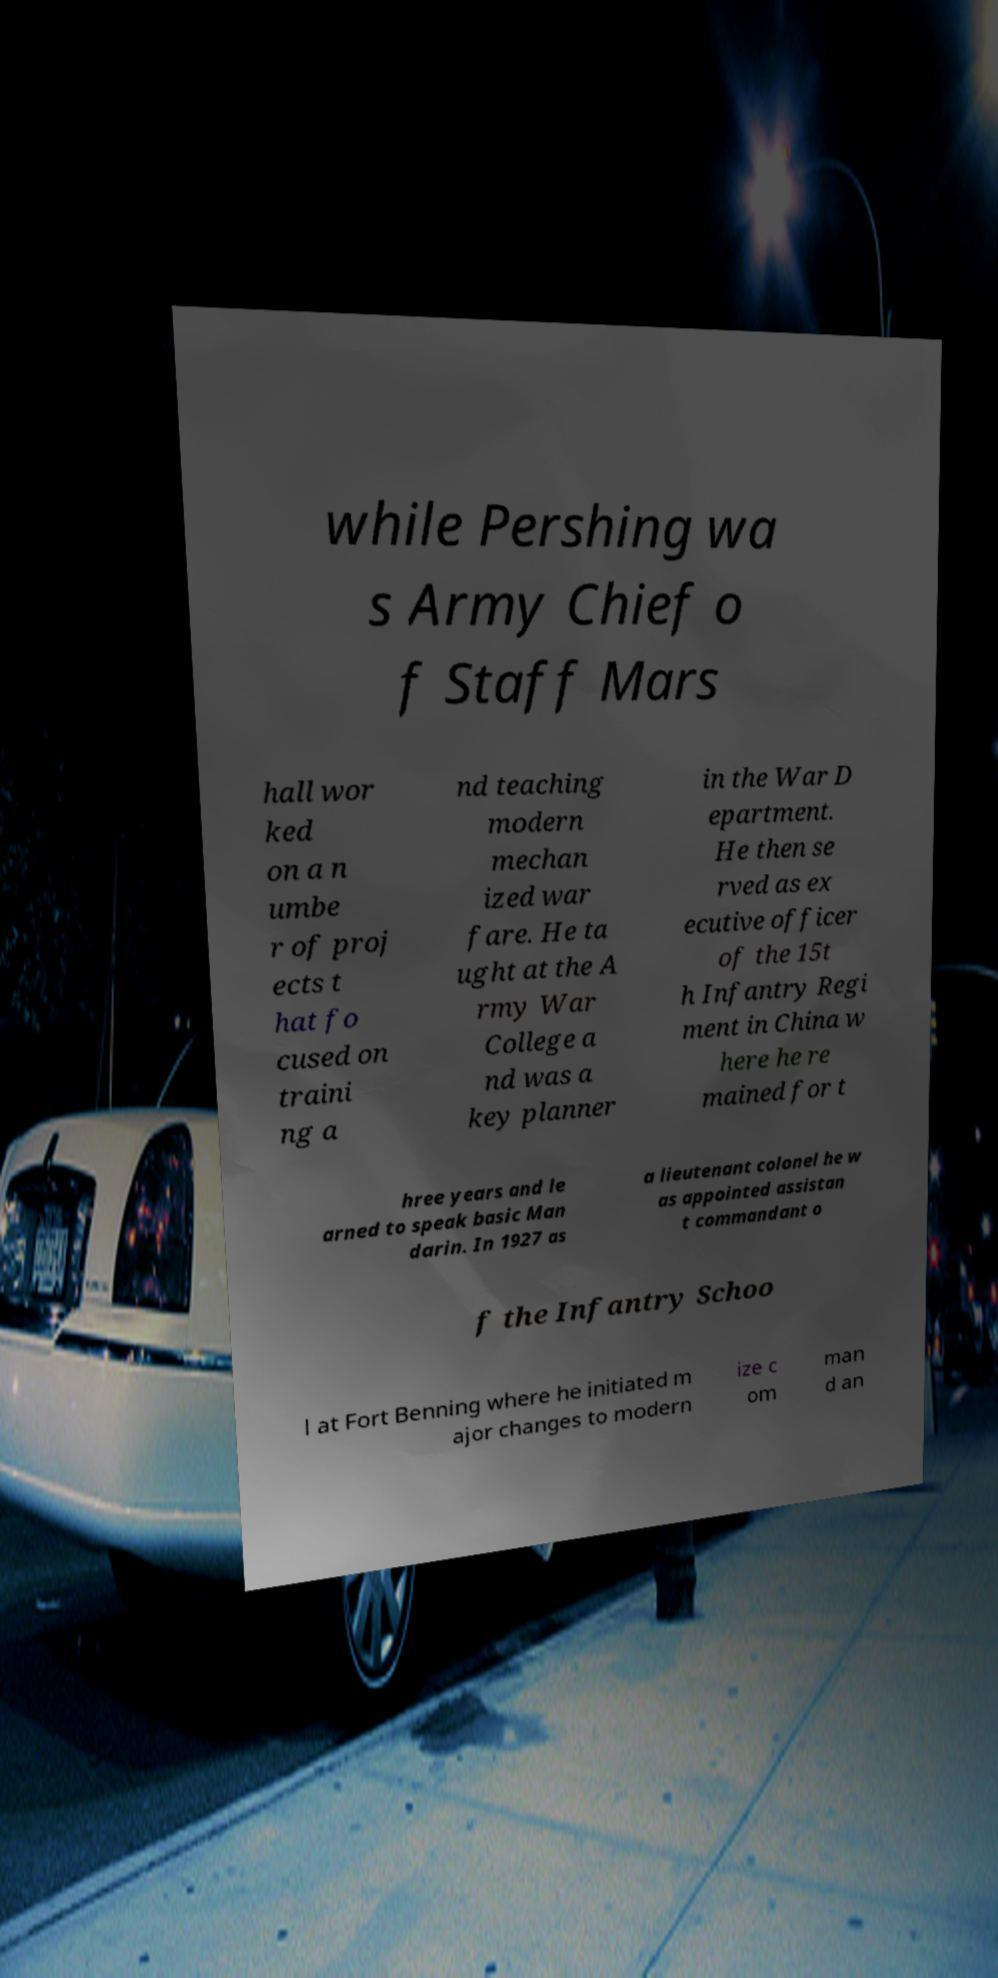Can you read and provide the text displayed in the image?This photo seems to have some interesting text. Can you extract and type it out for me? while Pershing wa s Army Chief o f Staff Mars hall wor ked on a n umbe r of proj ects t hat fo cused on traini ng a nd teaching modern mechan ized war fare. He ta ught at the A rmy War College a nd was a key planner in the War D epartment. He then se rved as ex ecutive officer of the 15t h Infantry Regi ment in China w here he re mained for t hree years and le arned to speak basic Man darin. In 1927 as a lieutenant colonel he w as appointed assistan t commandant o f the Infantry Schoo l at Fort Benning where he initiated m ajor changes to modern ize c om man d an 